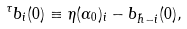Convert formula to latex. <formula><loc_0><loc_0><loc_500><loc_500>^ { \tau } b _ { i } ( 0 ) \equiv \eta ( \alpha _ { 0 } ) _ { i } - b _ { \tilde { h } - i } ( 0 ) ,</formula> 